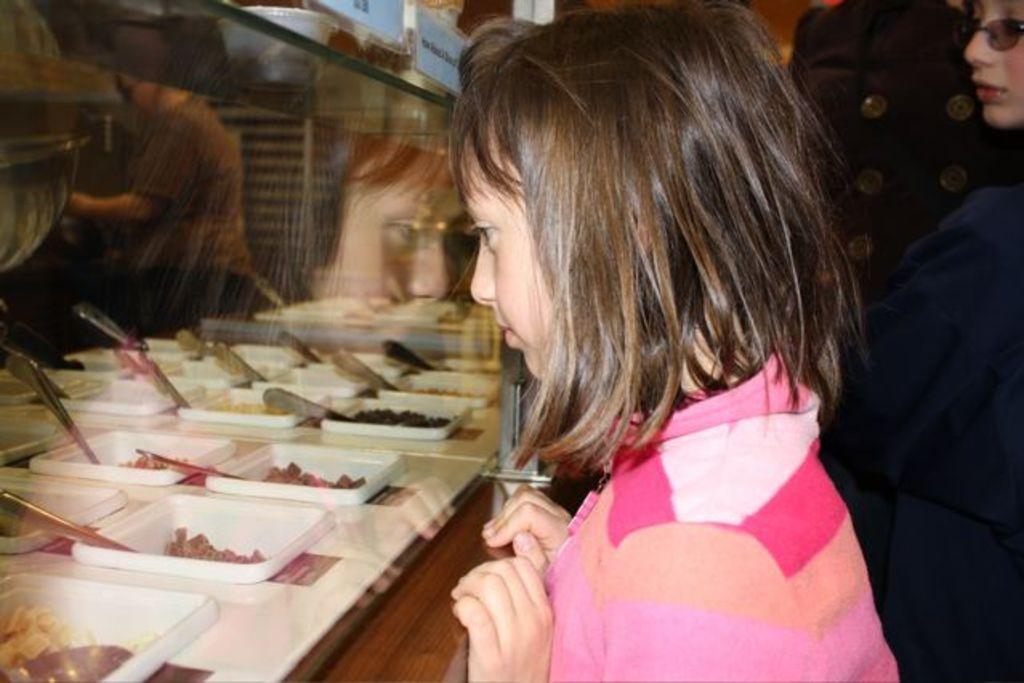Describe this image in one or two sentences. In the center of the image we can see a girl is standing in-front of table. On the right side of the image we can see some people are standing. On the left side of the image we can see the container which contains desserts with spoons. At the top of the image we can see the shelves, board, bowls and a person is standing, wall. 